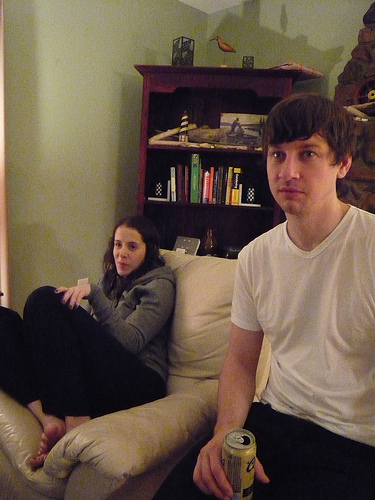<image>
Is the chair behind the man? Yes. From this viewpoint, the chair is positioned behind the man, with the man partially or fully occluding the chair. 